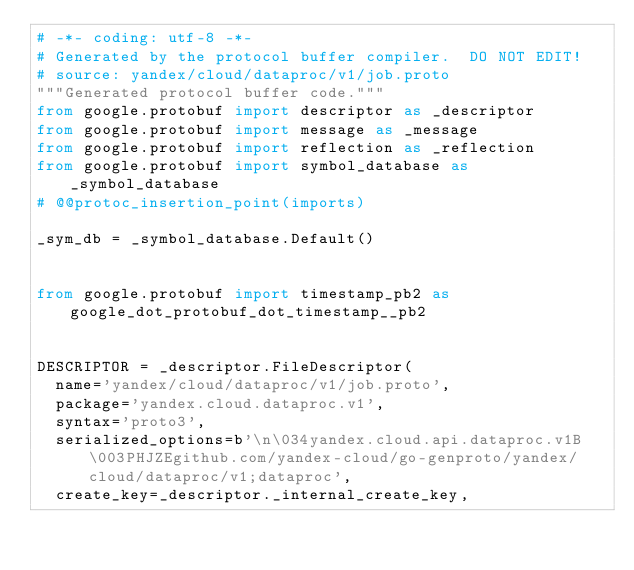Convert code to text. <code><loc_0><loc_0><loc_500><loc_500><_Python_># -*- coding: utf-8 -*-
# Generated by the protocol buffer compiler.  DO NOT EDIT!
# source: yandex/cloud/dataproc/v1/job.proto
"""Generated protocol buffer code."""
from google.protobuf import descriptor as _descriptor
from google.protobuf import message as _message
from google.protobuf import reflection as _reflection
from google.protobuf import symbol_database as _symbol_database
# @@protoc_insertion_point(imports)

_sym_db = _symbol_database.Default()


from google.protobuf import timestamp_pb2 as google_dot_protobuf_dot_timestamp__pb2


DESCRIPTOR = _descriptor.FileDescriptor(
  name='yandex/cloud/dataproc/v1/job.proto',
  package='yandex.cloud.dataproc.v1',
  syntax='proto3',
  serialized_options=b'\n\034yandex.cloud.api.dataproc.v1B\003PHJZEgithub.com/yandex-cloud/go-genproto/yandex/cloud/dataproc/v1;dataproc',
  create_key=_descriptor._internal_create_key,</code> 